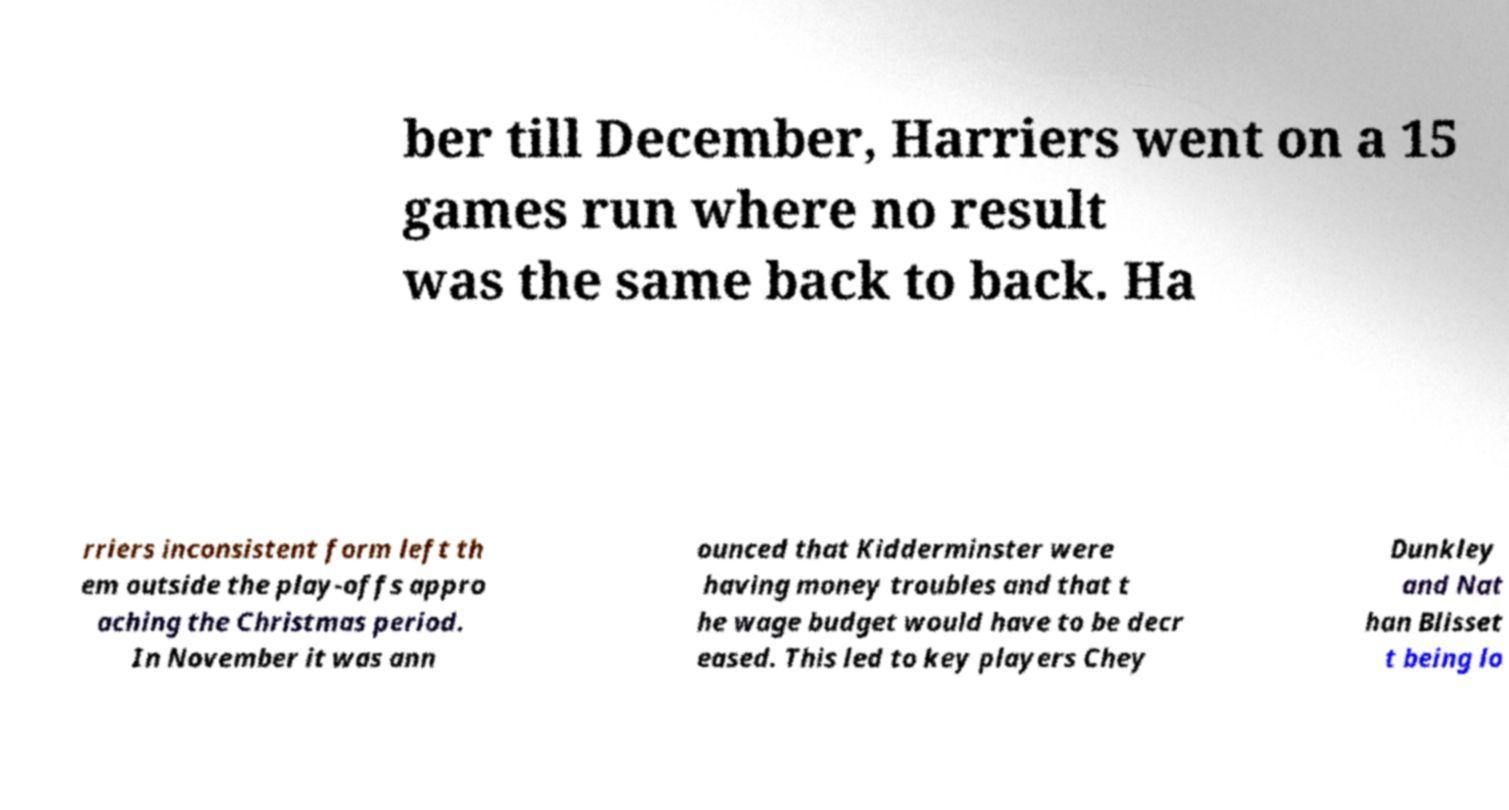I need the written content from this picture converted into text. Can you do that? ber till December, Harriers went on a 15 games run where no result was the same back to back. Ha rriers inconsistent form left th em outside the play-offs appro aching the Christmas period. In November it was ann ounced that Kidderminster were having money troubles and that t he wage budget would have to be decr eased. This led to key players Chey Dunkley and Nat han Blisset t being lo 